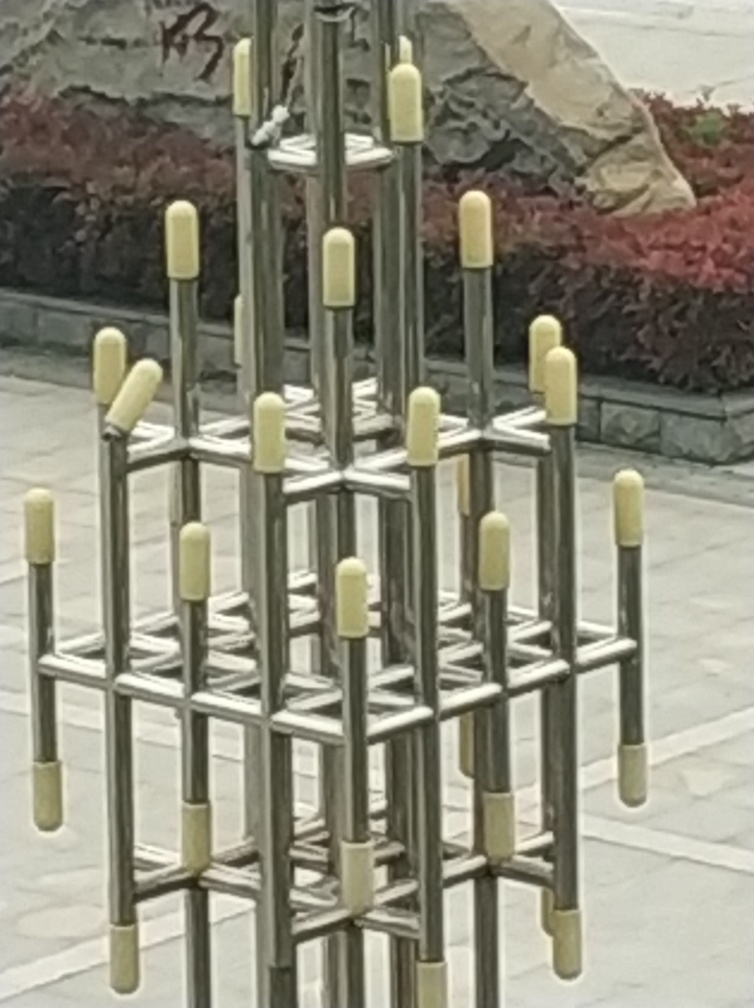Are all the texture details of the green plants in the background present? The image provided has a limited resolution, which affects the visibility of fine texture details. While we can see the greenery and distinguish variations in color, specific texture details of the green plants in the background are not fully discernible due to the image's quality and focus being on the metallic structure in the foreground. 